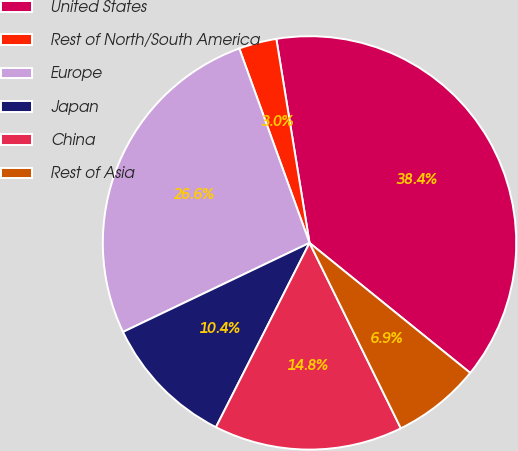Convert chart. <chart><loc_0><loc_0><loc_500><loc_500><pie_chart><fcel>United States<fcel>Rest of North/South America<fcel>Europe<fcel>Japan<fcel>China<fcel>Rest of Asia<nl><fcel>38.39%<fcel>2.95%<fcel>26.57%<fcel>10.43%<fcel>14.76%<fcel>6.89%<nl></chart> 